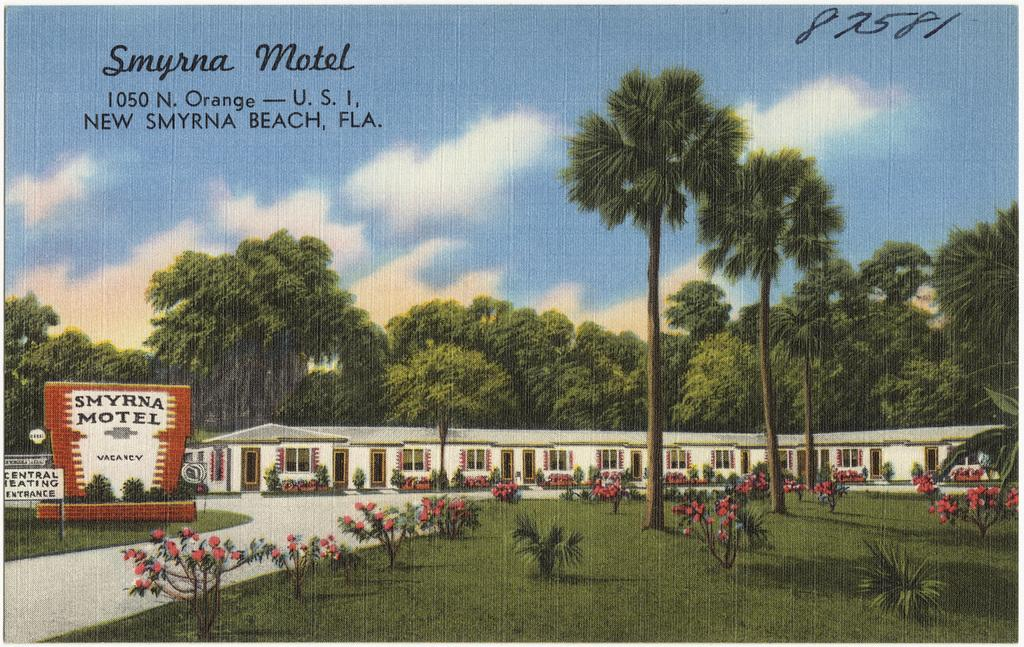What type of vegetation is on the right side of the image? There are trees on the right side of the image. What structure is located in the middle of the image? There is a house in the middle of the image. What is visible at the top of the image? The sky is visible at the top of the image. How many owls can be seen in the trees on the right side of the image? There are no owls present in the image; it only features trees. Are there any ants visible on the house in the middle of the image? There are no ants visible on the house in the image; it only features a house. 